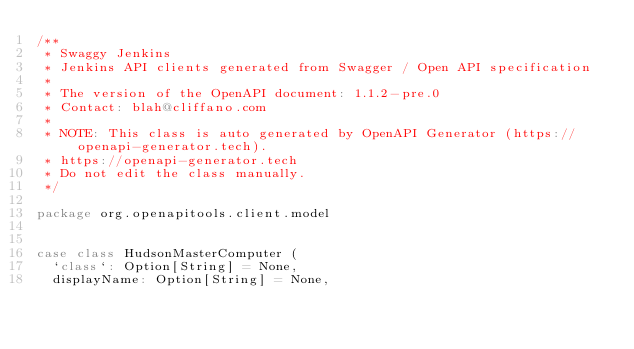<code> <loc_0><loc_0><loc_500><loc_500><_Scala_>/**
 * Swaggy Jenkins
 * Jenkins API clients generated from Swagger / Open API specification
 *
 * The version of the OpenAPI document: 1.1.2-pre.0
 * Contact: blah@cliffano.com
 *
 * NOTE: This class is auto generated by OpenAPI Generator (https://openapi-generator.tech).
 * https://openapi-generator.tech
 * Do not edit the class manually.
 */

package org.openapitools.client.model


case class HudsonMasterComputer (
  `class`: Option[String] = None,
  displayName: Option[String] = None,</code> 